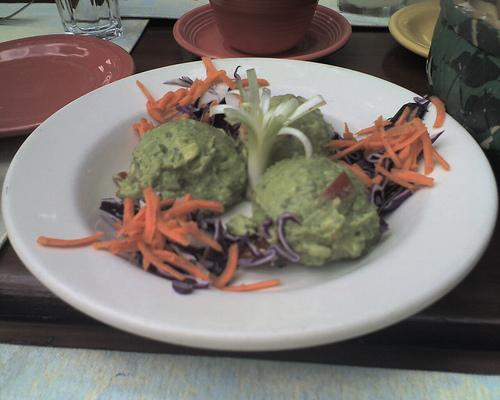What type of meal does this appear to be? vegetarian 